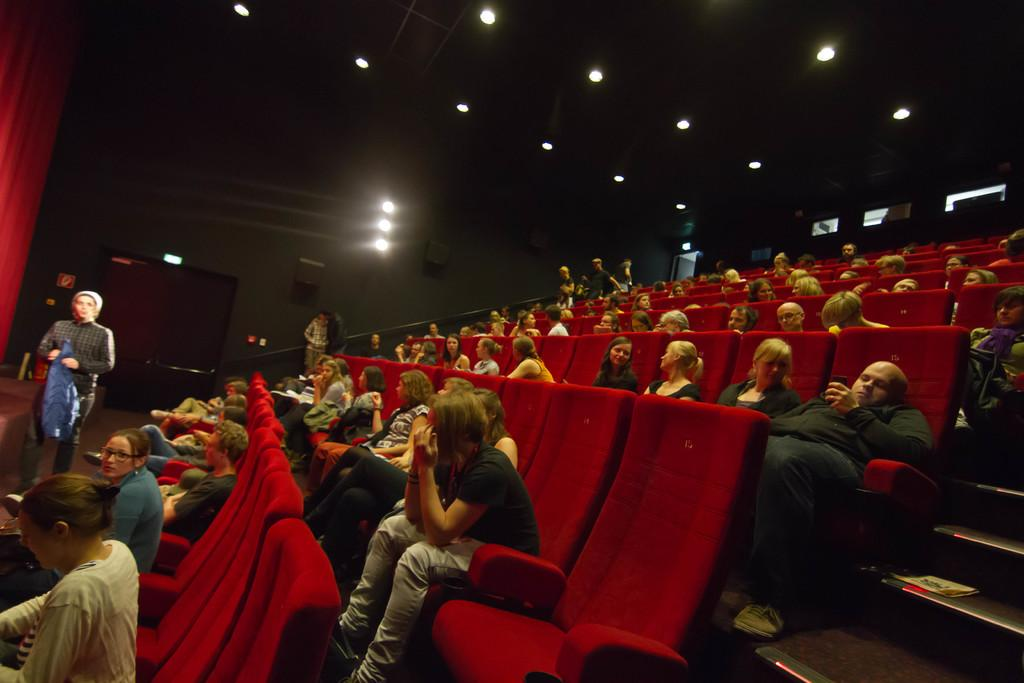What are the people in the image doing? The people in the image are sitting on chairs. What is in front of the people? There is a red curtain in front of the people. What can be seen on top of the roof in the image? There are lights on top of the roof in the image. What is visible on the backside of the image? There is a door visible on the backside of the image. Where is the kettle placed in the image? There is no kettle present in the image. What type of frame surrounds the people in the image? The image does not show a frame surrounding the people; it is a photograph or digital image without a physical frame. 